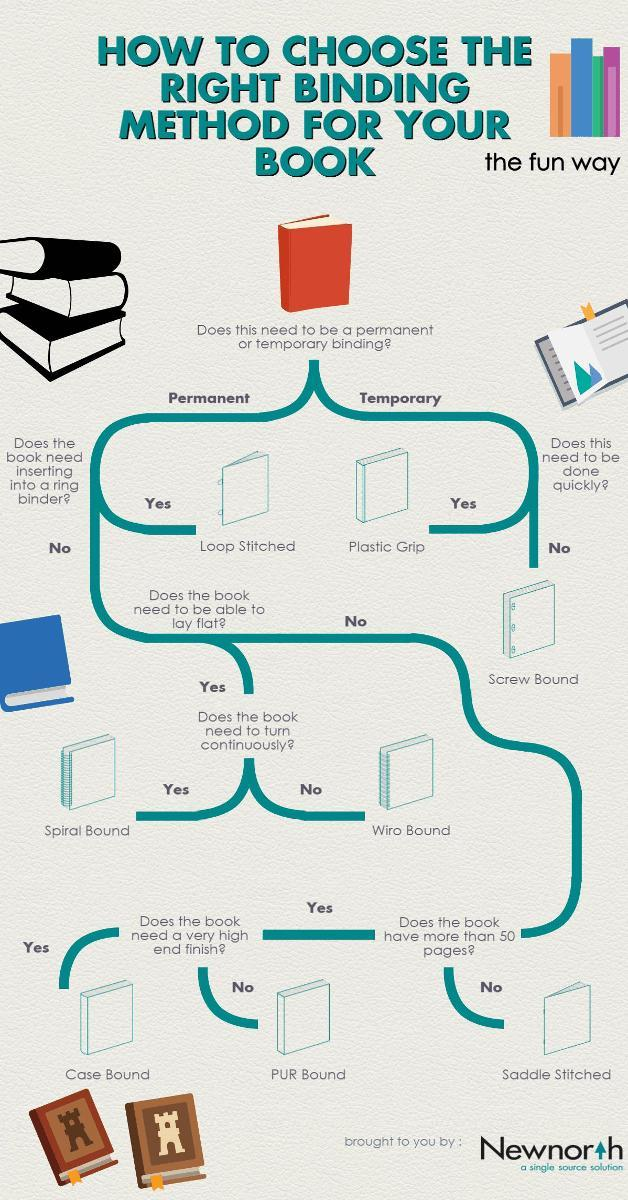Which method is best for a quick temporary binding?
Answer the question with a short phrase. Plastic Grip Which binding is best for a book that needs to turn continuously? Spiral bound Which binding is best for a book that needs a very high end finish? Case Bound Which binding method is suitable for the permanent binding of a book in which books need to insert into a ring binder? Loop Stitched 